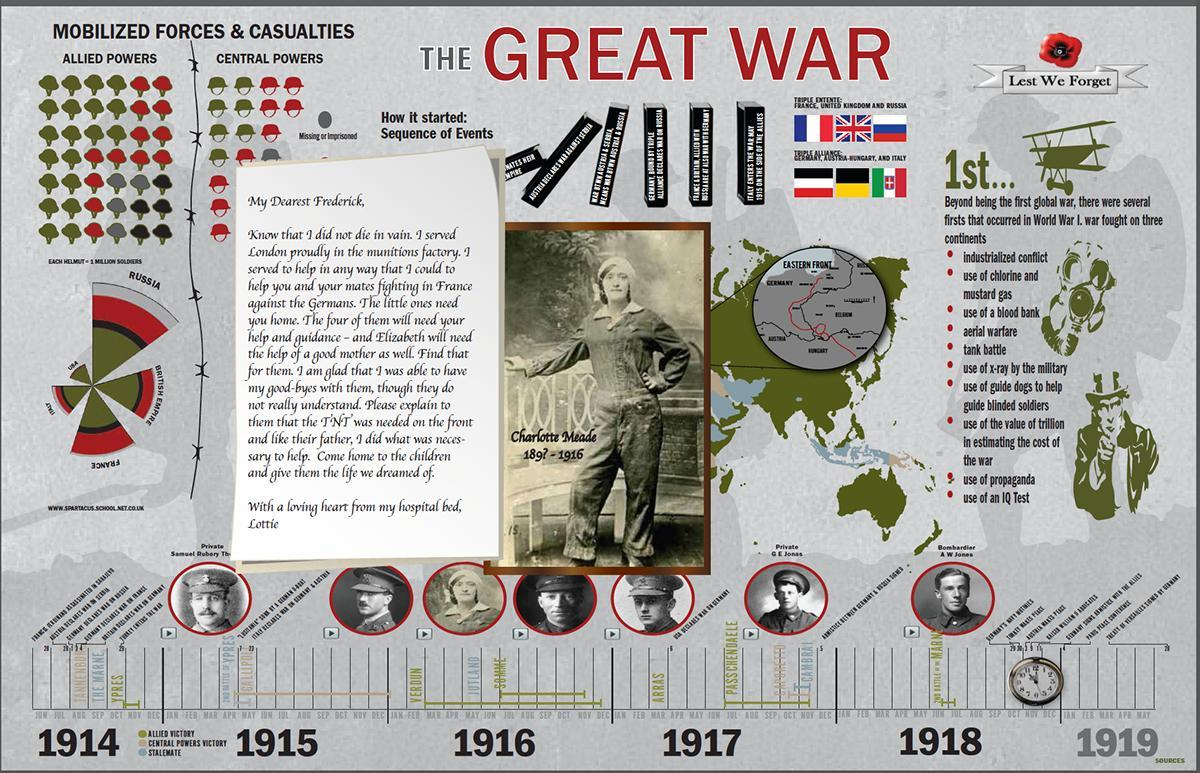What is listed second among the firsts of the World War 1?
Answer the question with a short phrase. use of chlorine and mustard gas What is the last point mentioned among the firsts of the World War 1? use of an IQ Test 